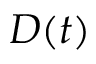Convert formula to latex. <formula><loc_0><loc_0><loc_500><loc_500>D ( t )</formula> 